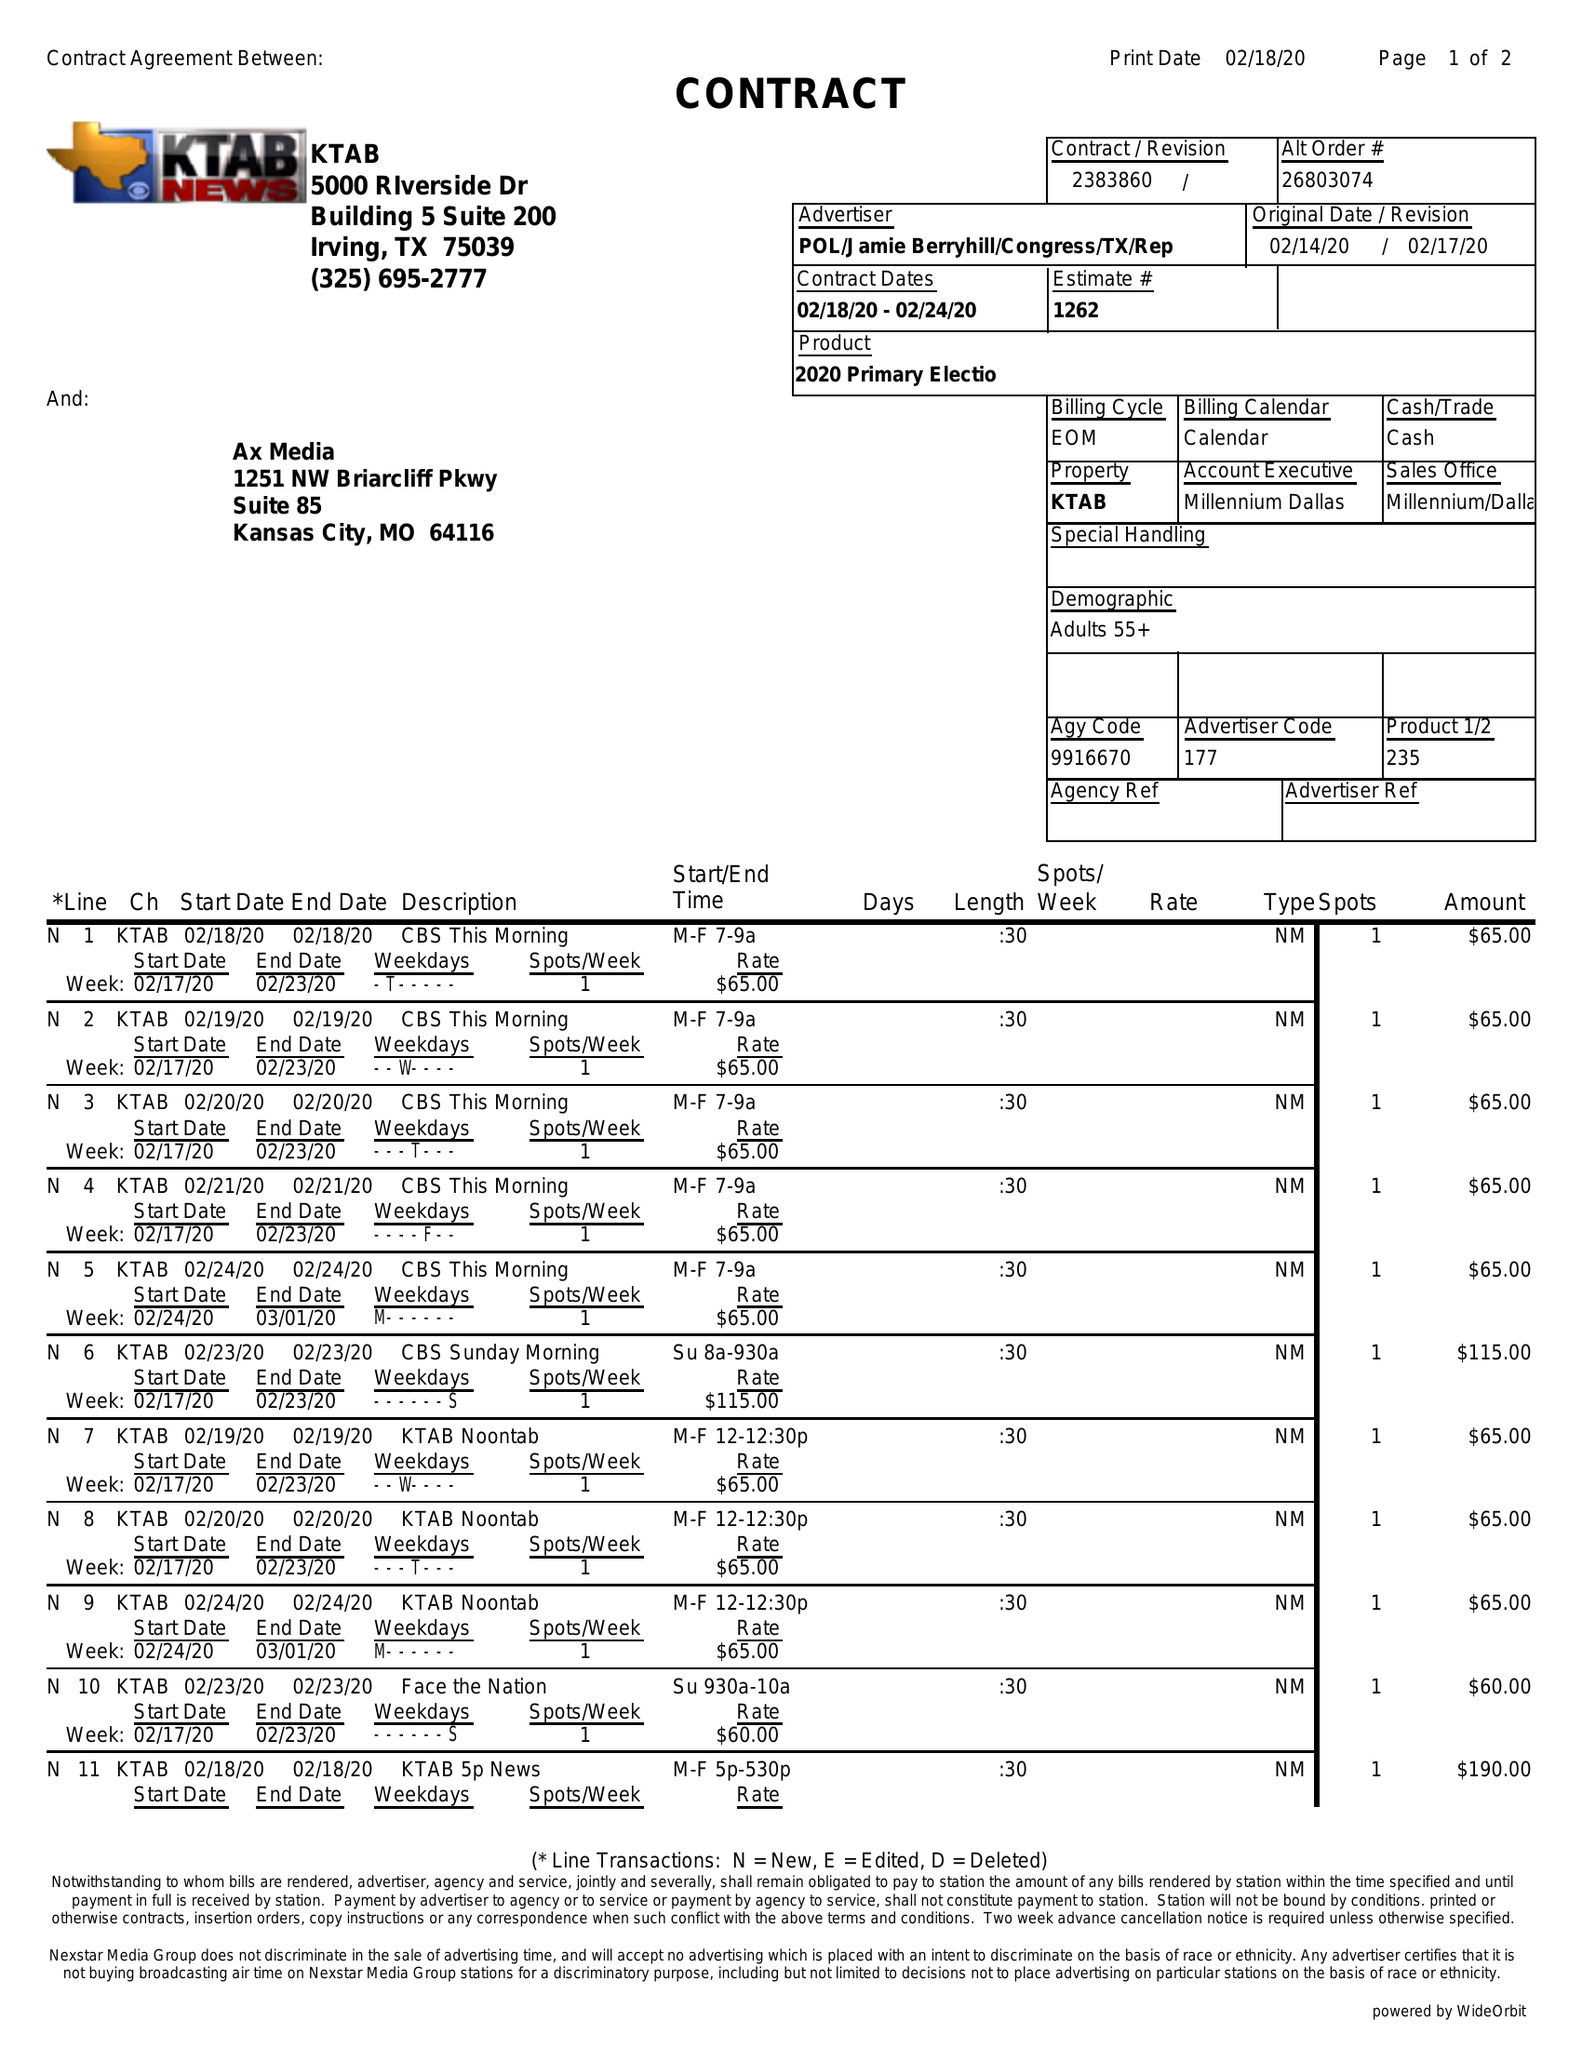What is the value for the advertiser?
Answer the question using a single word or phrase. POL/JAMIEBERRYHILL/CONGRESS/TX/REP 